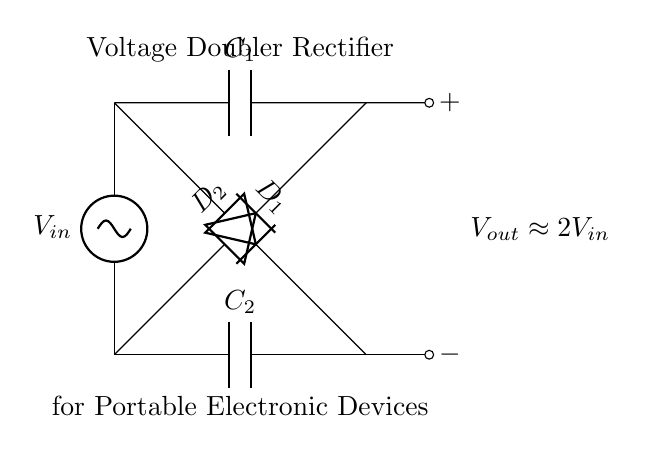What is the input voltage type for this rectifier? The input voltage is an alternating current (AC) type, indicated by the AC source symbol used in the circuit.
Answer: AC How many diodes are present in the circuit? There are two diodes shown in the circuit diagram, labeled as D1 and D2, which are used to rectify the AC signal.
Answer: 2 What is the function of capacitors in this circuit? The capacitors C1 and C2 are used to store charge and smooth the output voltage, effectively increasing the voltage from the rectifier output.
Answer: Store charge What does the output voltage approximately equal? The output voltage is approximately double the input voltage, as indicated by Vout being defined as approximately 2Vin in the diagram.
Answer: 2Vin What components are used in this voltage doubler rectifier? The main components identified in the circuit are two diodes (D1, D2) and two capacitors (C1, C2) that work together to convert AC to a higher DC voltage.
Answer: Diodes and capacitors What is the purpose of this voltage doubler rectifier circuit? The purpose of the circuit is to boost the power output, enabling portable electronic devices, like those used by field reporters, to function effectively with higher voltage.
Answer: Boost power output How does the connection of diodes affect the output? The diodes are connected in a configuration that allows them to alternately conduct current during positive and negative halves of the AC cycle, effectively doubling the output voltage.
Answer: Doubles output voltage 